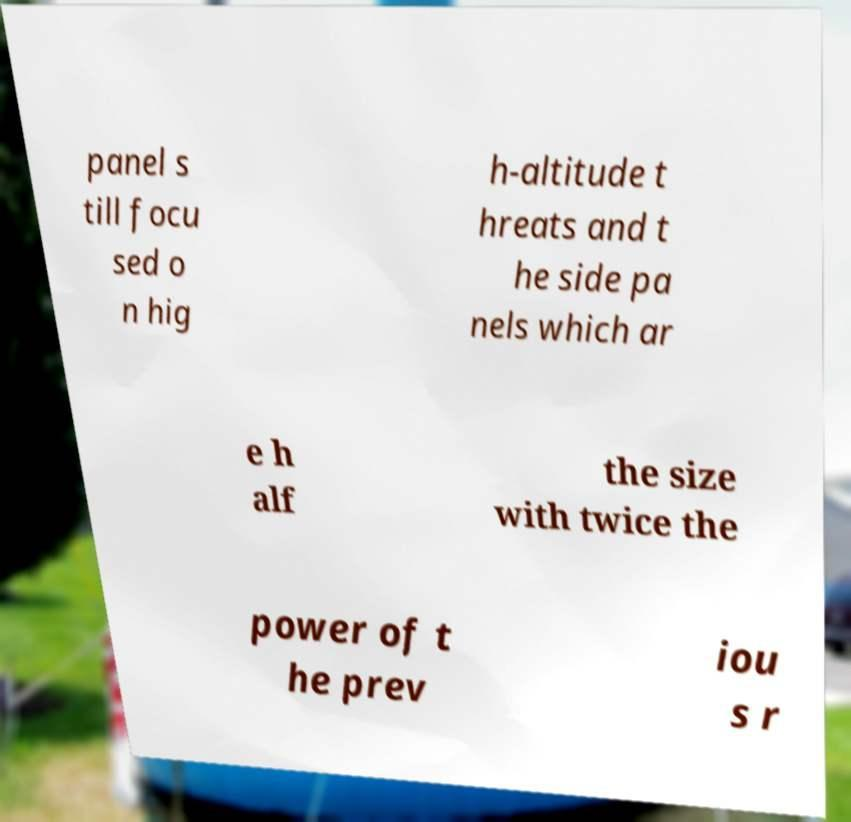What messages or text are displayed in this image? I need them in a readable, typed format. panel s till focu sed o n hig h-altitude t hreats and t he side pa nels which ar e h alf the size with twice the power of t he prev iou s r 